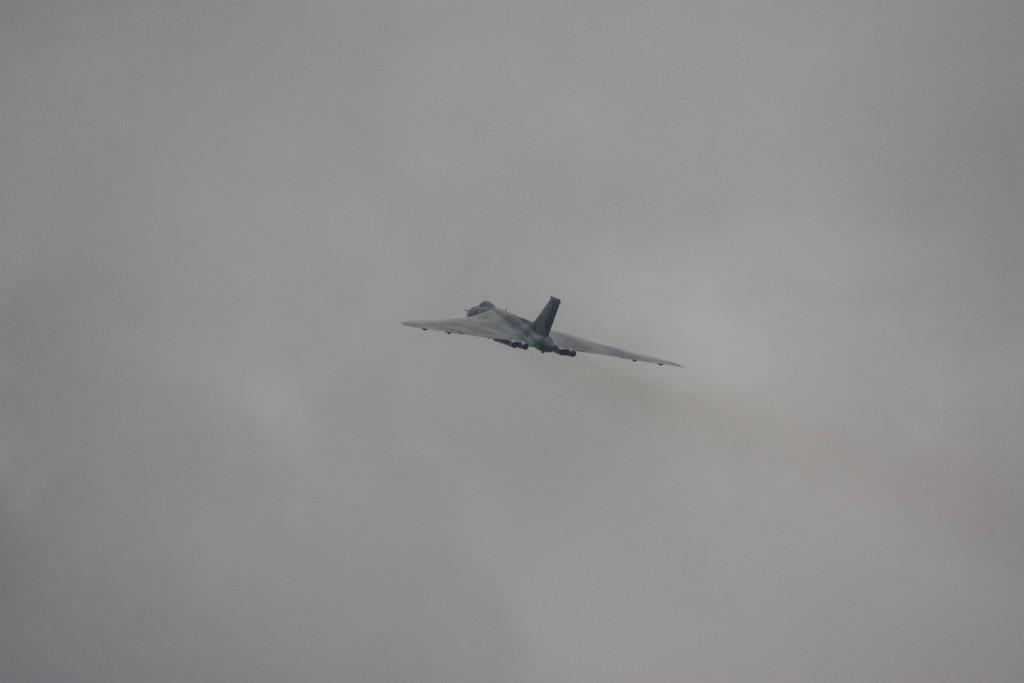What is the main subject of the image? The main subject of the image is an airplane. What is the airplane doing in the image? The airplane is flying in the sky. What type of event is taking place in the image? There is no event taking place in the image; it simply shows an airplane flying in the sky. Can you recite a verse that is related to the image? There is no verse associated with the image; it is a straightforward depiction of an airplane flying in the sky. 